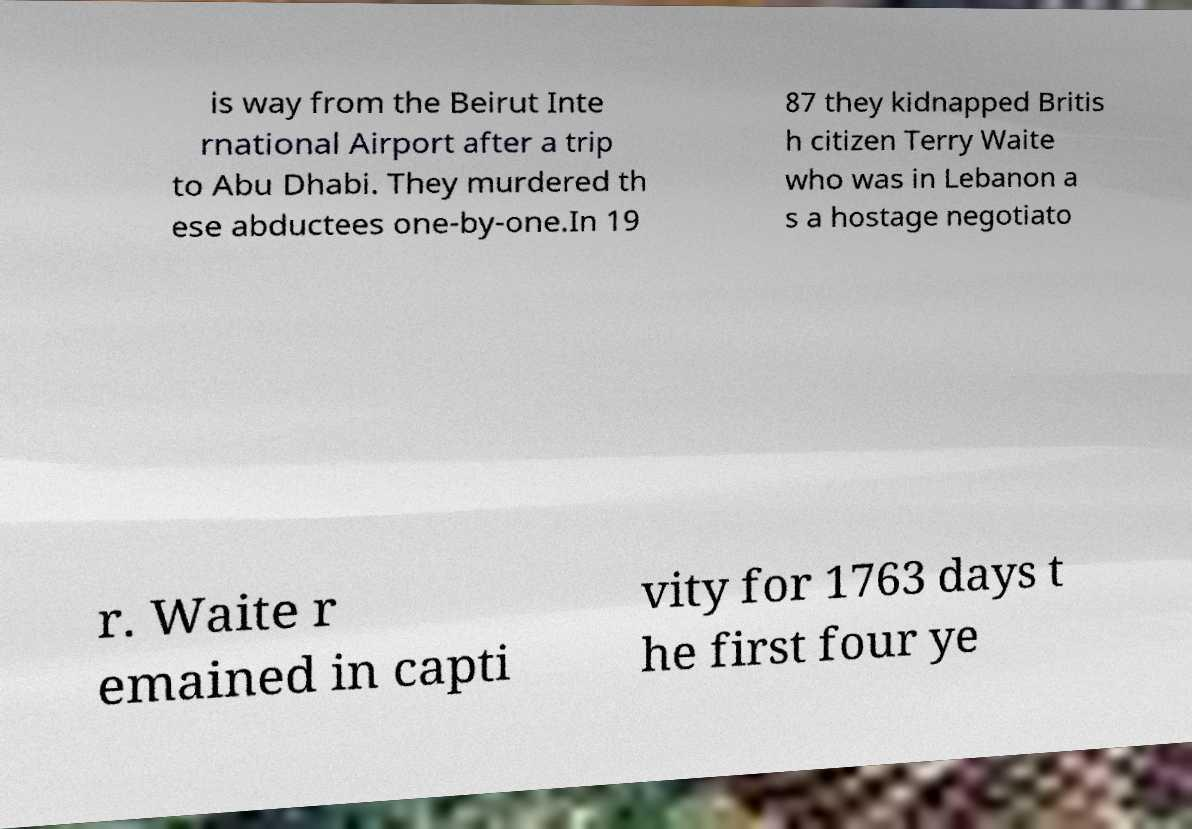Please identify and transcribe the text found in this image. is way from the Beirut Inte rnational Airport after a trip to Abu Dhabi. They murdered th ese abductees one-by-one.In 19 87 they kidnapped Britis h citizen Terry Waite who was in Lebanon a s a hostage negotiato r. Waite r emained in capti vity for 1763 days t he first four ye 